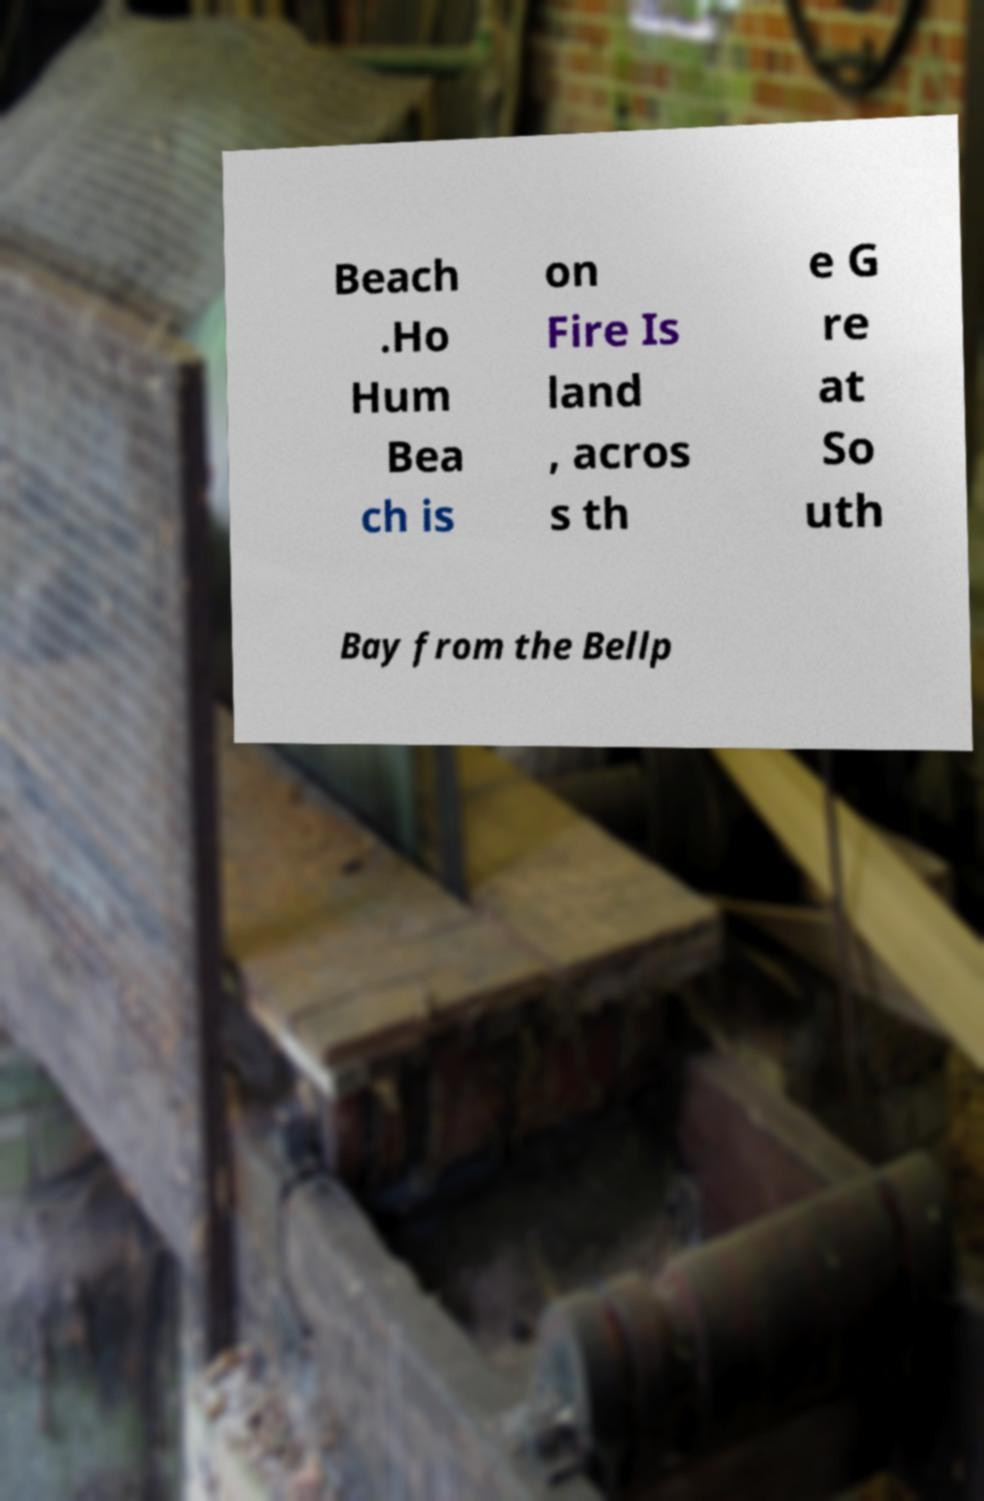Please identify and transcribe the text found in this image. Beach .Ho Hum Bea ch is on Fire Is land , acros s th e G re at So uth Bay from the Bellp 